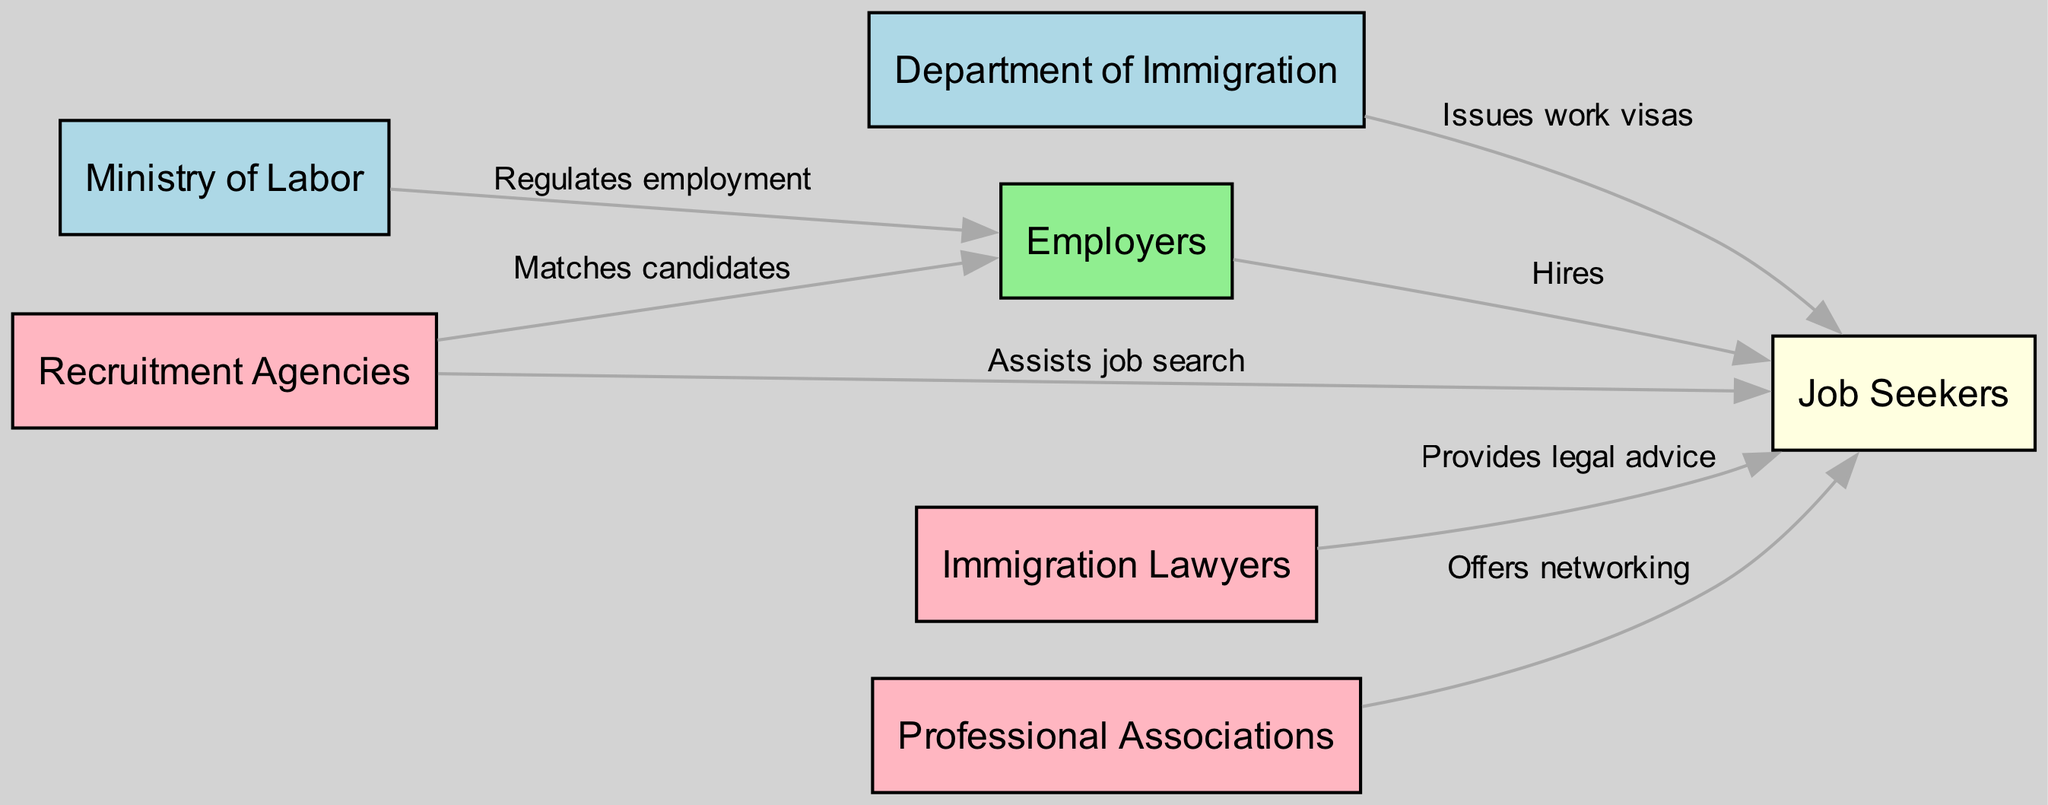What is the total number of nodes in the diagram? The diagram contains seven nodes, which includes the Department of Immigration, Ministry of Labor, Employers, Job Seekers, Immigration Lawyers, Recruitment Agencies, and Professional Associations. Each of these entities represents a crucial component in the immigration and job placement process.
Answer: 7 What type of node is "Employers"? "Employers" is categorized as a central entity involved in the job placement process. In the diagram, it is colored light green, indicating that it is an employer node that actively hires job seekers.
Answer: Employers Which entity provides legal advice to job seekers? The "Immigration Lawyers" node provides legal advice to job seekers, as indicated by the direct connection from Immigration Lawyers to Job Seekers labeled "Provides legal advice."
Answer: Immigration Lawyers What is the relationship between the "Department of Immigration" and "Job Seekers"? The relationship is that the Department of Immigration issues work visas to Job Seekers, which allows them to legally work in the country. This is represented by the edge labeled "Issues work visas."
Answer: Issues work visas How many edges are there in the diagram? The total number of edges in the diagram is six, connecting various nodes and indicating specific relationships and functions that these entities provide within the immigration and job placement process.
Answer: 6 What role do Recruitment Agencies play in the job placement process? Recruitment Agencies assist job seekers in their job search and also match candidates with employers, indicating their dual role in facilitating employment for immigrants.
Answer: Assists job search Which node connects Employers to Job Seekers? The "Employers" node connects directly to the "Job Seekers" node through the edge labeled "Hires," indicating that employers are the ones who hire job seekers.
Answer: Hires What type of node is "Professional Associations"? "Professional Associations" is a support service node that offers networking opportunities to job seekers, as represented in the diagram. It is colored light pink to indicate its supportive role.
Answer: Support service Which agency regulates employment in the diagram? The "Ministry of Labor" regulates employment within the context of the immigration and job placement process, indicating its authority over employment laws and practices.
Answer: Ministry of Labor 